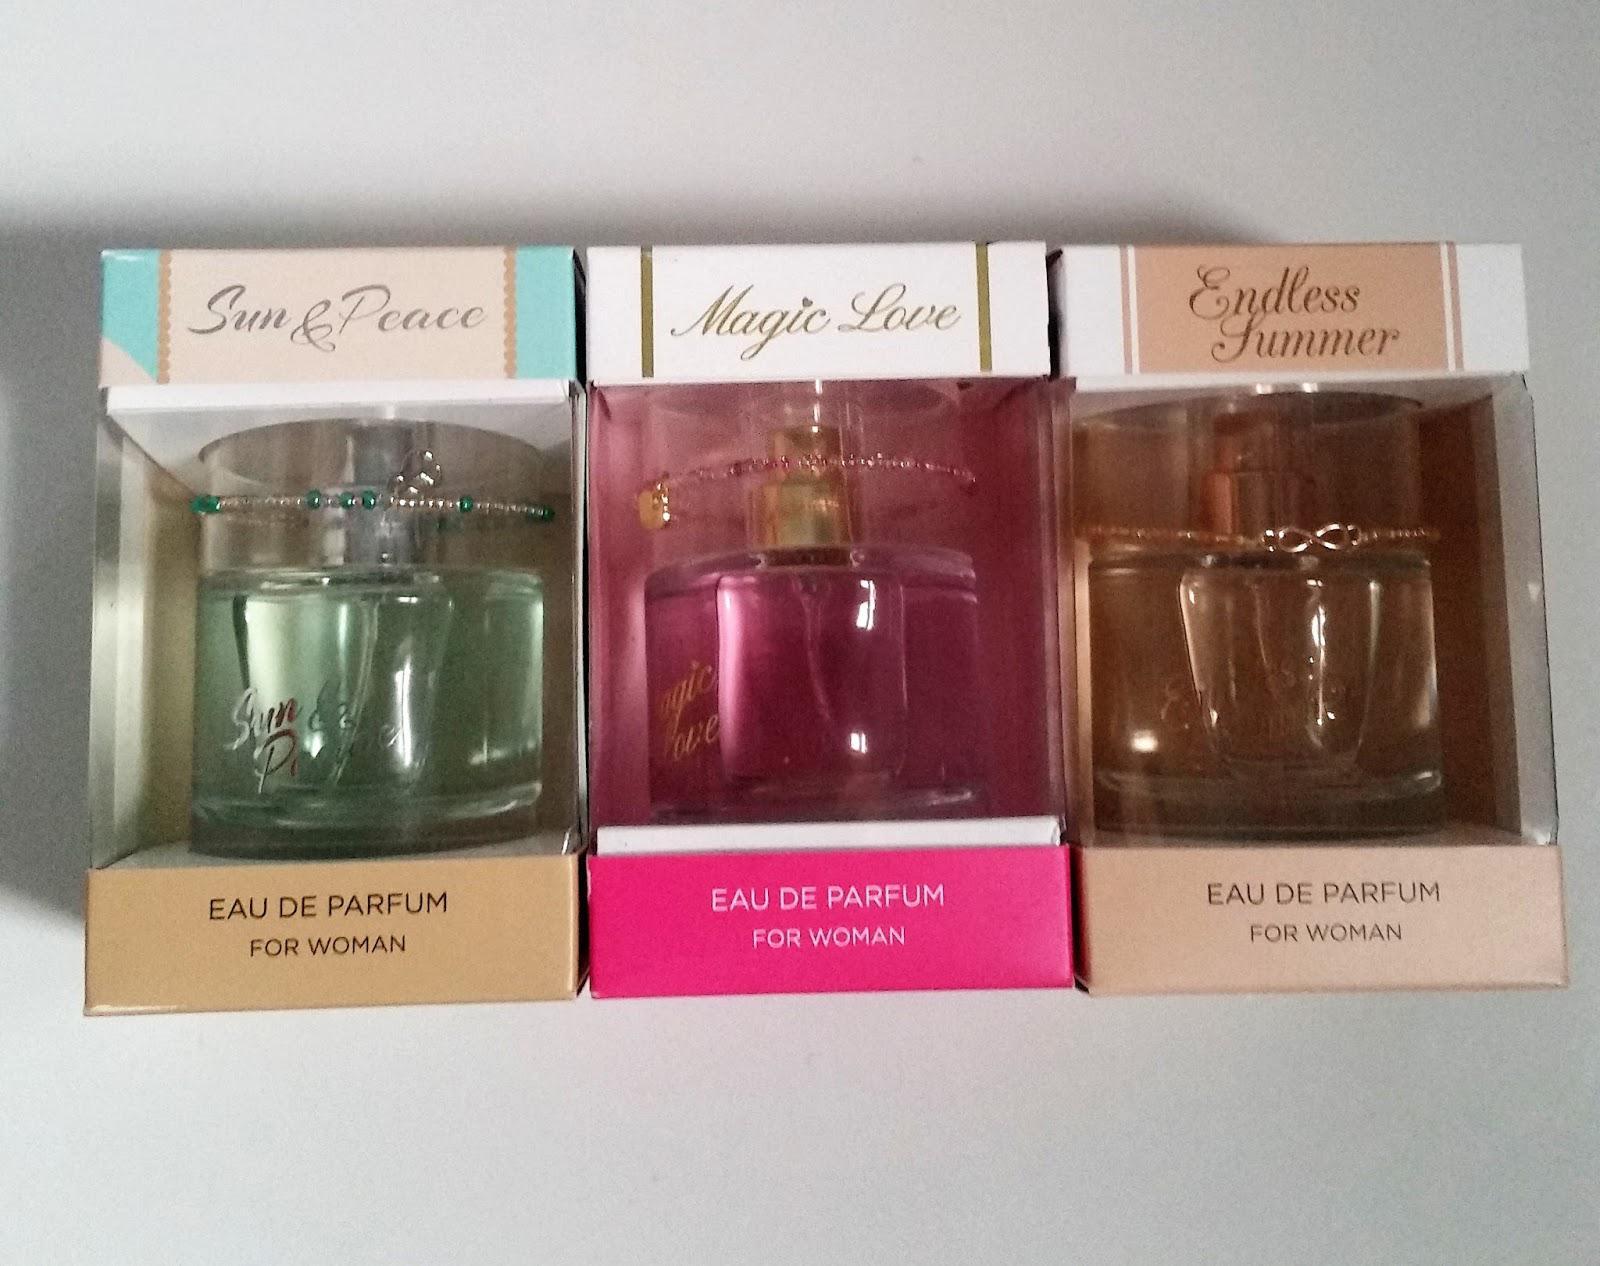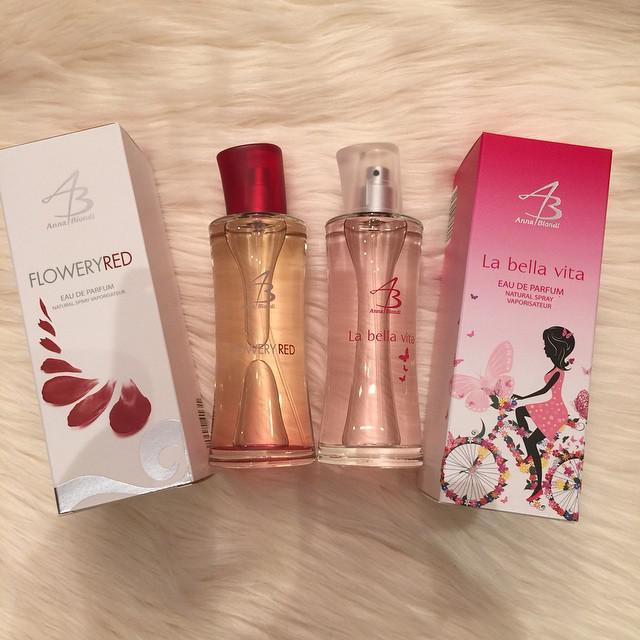The first image is the image on the left, the second image is the image on the right. Evaluate the accuracy of this statement regarding the images: "One box contains multiple items.". Is it true? Answer yes or no. No. 